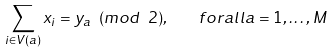Convert formula to latex. <formula><loc_0><loc_0><loc_500><loc_500>\sum _ { i \in V ( a ) } x _ { i } = y _ { a } \ ( m o d \ 2 ) , \quad f o r a l l a = 1 , \dots , M</formula> 